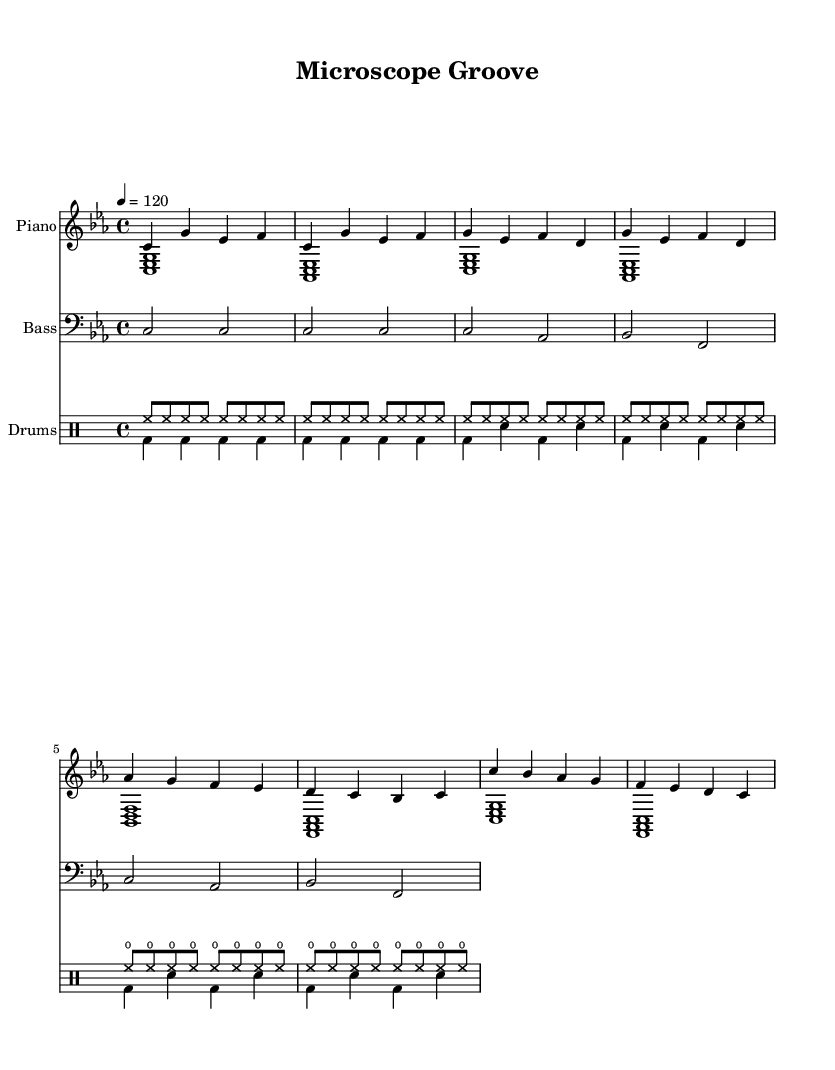What is the key signature of this music? The key signature is C minor, as indicated at the beginning of the score. C minor has three flats: B flat, E flat, and A flat.
Answer: C minor What is the time signature of this piece? The time signature shown at the beginning of the score is 4/4, which means there are four beats in each measure and the quarter note gets one beat.
Answer: 4/4 What is the tempo marking of this music? The tempo marking is indicated as "4 = 120," meaning that a quarter note should be played at 120 beats per minute.
Answer: 120 How many measures are in the chorus section? By examining the score, the chorus section is comprised of 2 measures. This can be counted by locating the group of notes designated for the chorus.
Answer: 2 What type of beats are primarily used in the drum parts? The drum parts feature both hi-hat (hho) and bass drum (bd) patterns, prominently utilizing 8th notes for upbeat rhythms which are characteristic of house music.
Answer: Hi-hat and bass drum What is the primary bass note during the verse? The bass line shows the notes C and A flat being used prominently during the verse of the piece. This is evident when analyzing the bass section alongside the score.
Answer: C What musical genre does this sheet music represent? The repetitive drum patterns, bass lines, and structure of the music suggest that it represents the house music genre, which combines elements of electronic dance music with a steady beat suitable for late-night listening.
Answer: House 